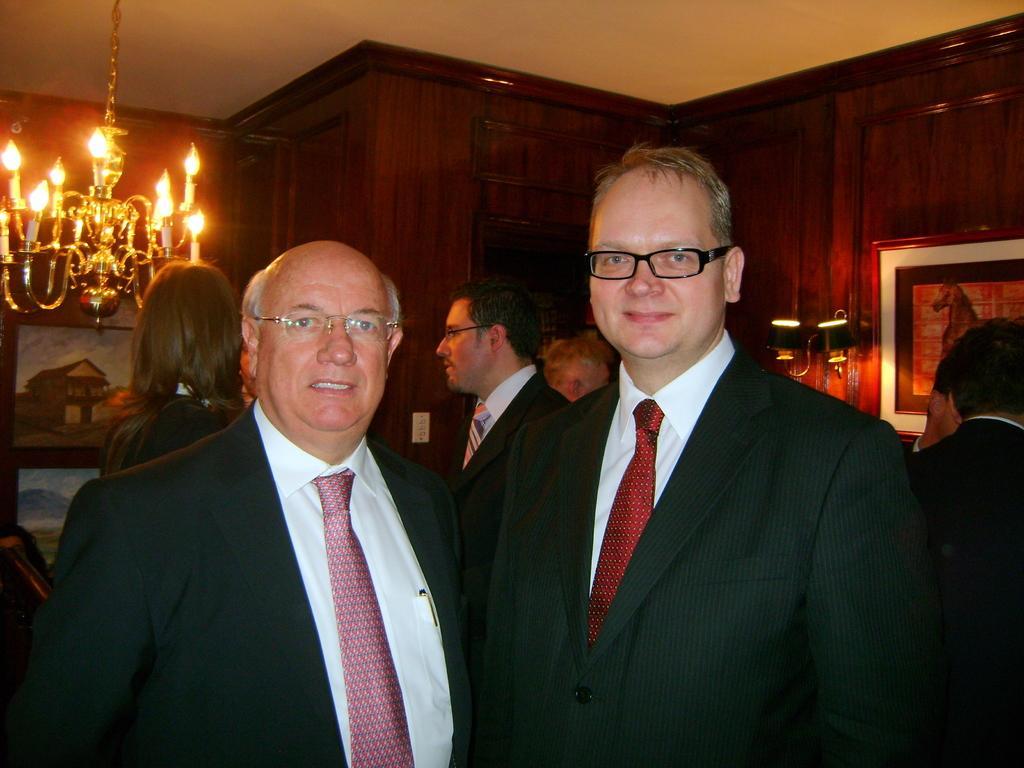In one or two sentences, can you explain what this image depicts? In this image there are some persons standing in the middle of this image. There is a wooden wall in the background. There is a photo frame on the right side of this image and there is a candle lights on the left side of this image, and there are some photo frames on the left side of this image. 